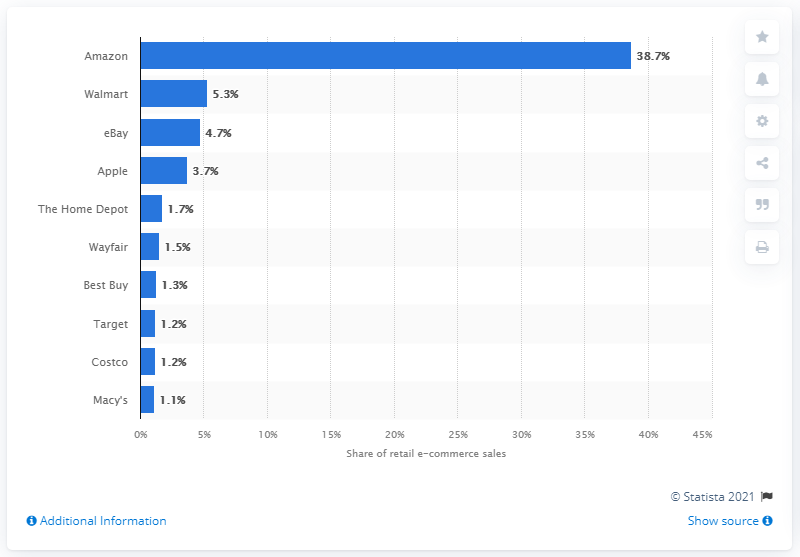Identify some key points in this picture. During the measured period, Amazon accounted for approximately 38.7% of retail e-commerce sales. 